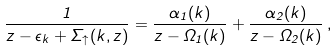<formula> <loc_0><loc_0><loc_500><loc_500>\frac { 1 } { z - \epsilon _ { k } + \Sigma _ { \uparrow } ( k , z ) } = \frac { \alpha _ { 1 } ( k ) } { z - \Omega _ { 1 } ( k ) } + \frac { \alpha _ { 2 } ( k ) } { z - \Omega _ { 2 } ( k ) } \, ,</formula> 